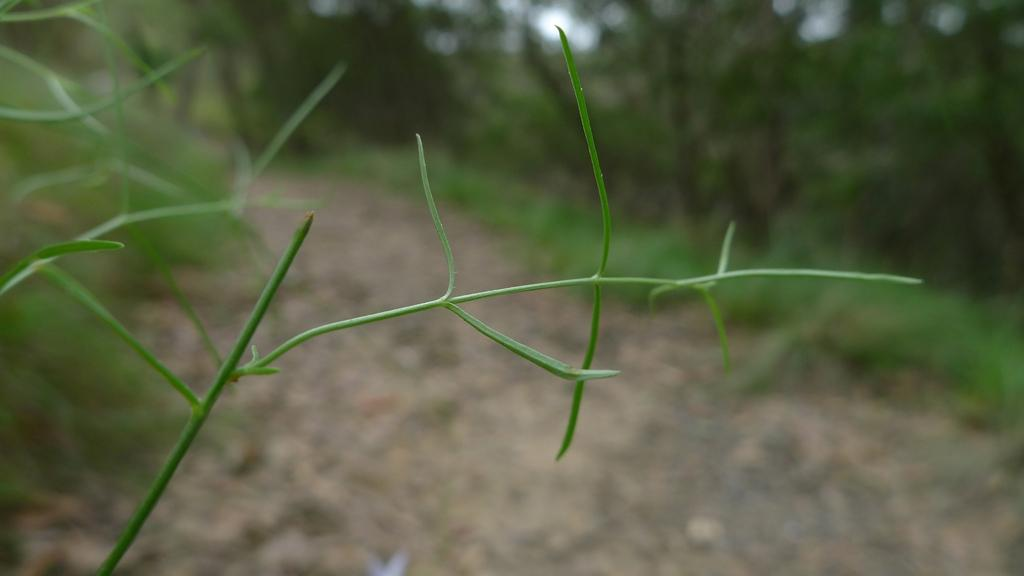What is located on the left side of the image? There is a plant on the left side of the image. What can be seen in the background of the image? There is greenery in the background of the image. What time of day is it in the image, given the presence of the sun? There is no sun present in the image, so it cannot be determined from the image alone. 